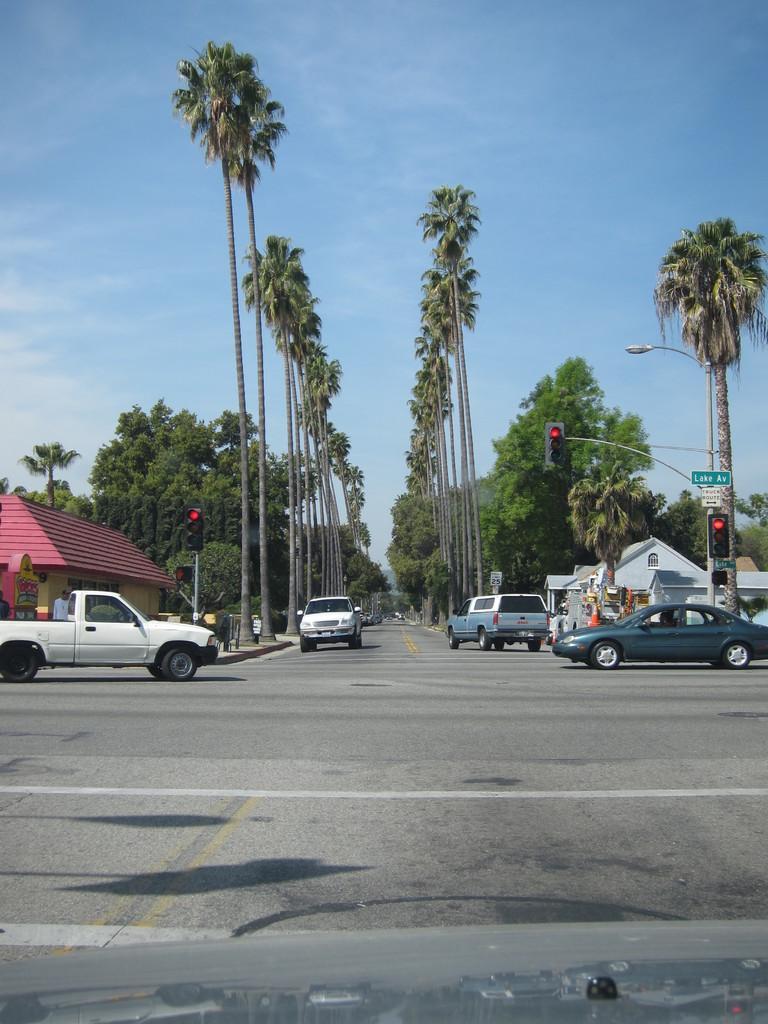Describe this image in one or two sentences. In this image I can see this is the road, few vehicles are moving on this, there are traffic lights on either side of this road and also there are trees. On the left side there is a house, at the top, it is the sky. 